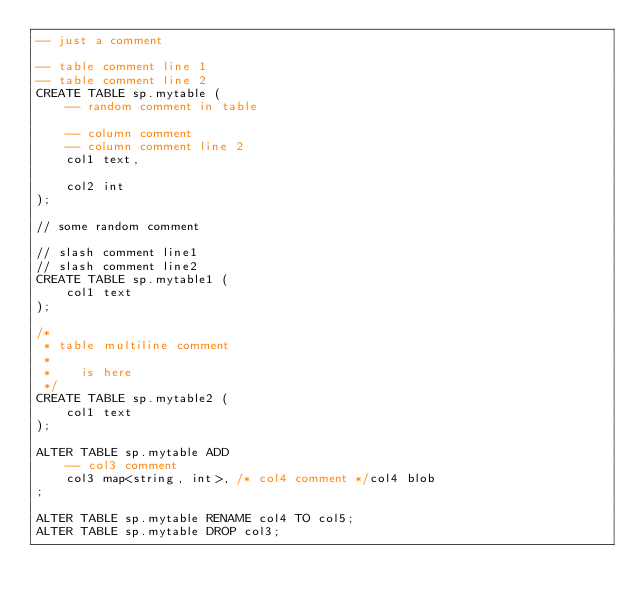<code> <loc_0><loc_0><loc_500><loc_500><_SQL_>-- just a comment

-- table comment line 1
-- table comment line 2
CREATE TABLE sp.mytable (
    -- random comment in table

    -- column comment
    -- column comment line 2
    col1 text,

    col2 int
);

// some random comment

// slash comment line1
// slash comment line2
CREATE TABLE sp.mytable1 (
	col1 text
);

/*
 * table multiline comment
 *
 *    is here
 */
CREATE TABLE sp.mytable2 (
	col1 text
);

ALTER TABLE sp.mytable ADD
	-- col3 comment
	col3 map<string, int>, /* col4 comment */col4 blob
;

ALTER TABLE sp.mytable RENAME col4 TO col5;
ALTER TABLE sp.mytable DROP col3;</code> 